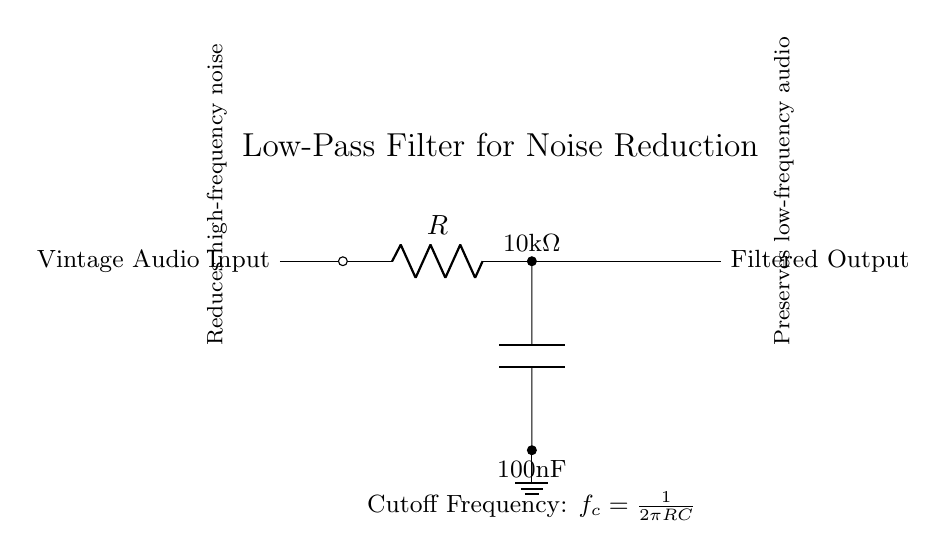What is the value of the resistor in this circuit? The circuit diagram indicates that the resistor has a label of 10kΩ, which is displayed next to the component.
Answer: 10kΩ What component is connected to the resistor? The circuit diagram shows that a capacitor is directly connected to the resistor, indicated by the line connecting the two.
Answer: Capacitor What is the function of this circuit? This circuit is designed to reduce high-frequency noise and preserve low-frequency audio, which is stated in the explanation section of the circuit.
Answer: Noise reduction What is the cutoff frequency formula represented in this circuit? The diagram provides the cutoff frequency formula, which is stated as fc = 1/(2πRC), where R is the resistance and C is the capacitance.
Answer: fc = 1/(2πRC) Why is a low-pass filter useful for vintage audio recordings? A low-pass filter is useful because it allows low-frequency sounds, such as vocals and music, to pass through while attenuating high-frequency noise, improving the quality of vintage audio recordings.
Answer: Improves audio quality What is the capacitance value in this circuit? The circuit shows a capacitor labeled with a value of 100nF, indicating the specific amount of capacitance.
Answer: 100nF What type of filter is this circuit classified as? Based on the components and configuration in the diagram, this circuit is classified as a low-pass filter, which is explicitly stated at the top of the diagram.
Answer: Low-pass filter 